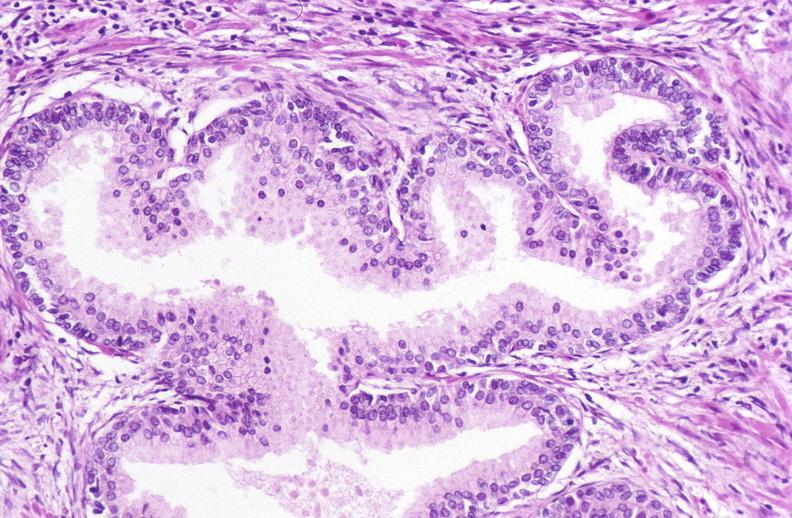does this image show prostate, benign prostatic hyperplasia?
Answer the question using a single word or phrase. Yes 